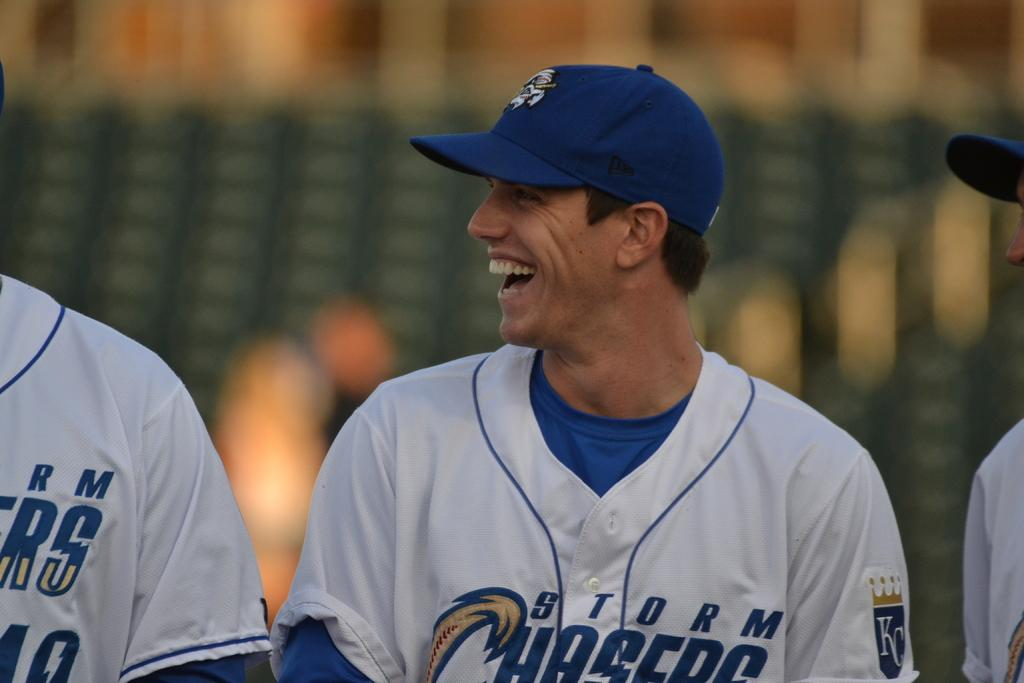<image>
Render a clear and concise summary of the photo. A man on the Storm Chasers team smiles and looks off to his right. 